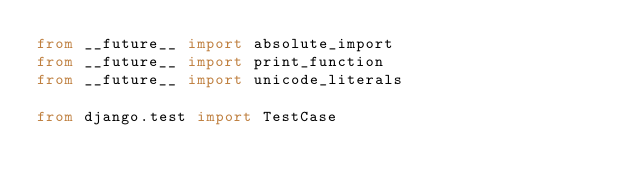Convert code to text. <code><loc_0><loc_0><loc_500><loc_500><_Python_>from __future__ import absolute_import
from __future__ import print_function
from __future__ import unicode_literals

from django.test import TestCase
</code> 